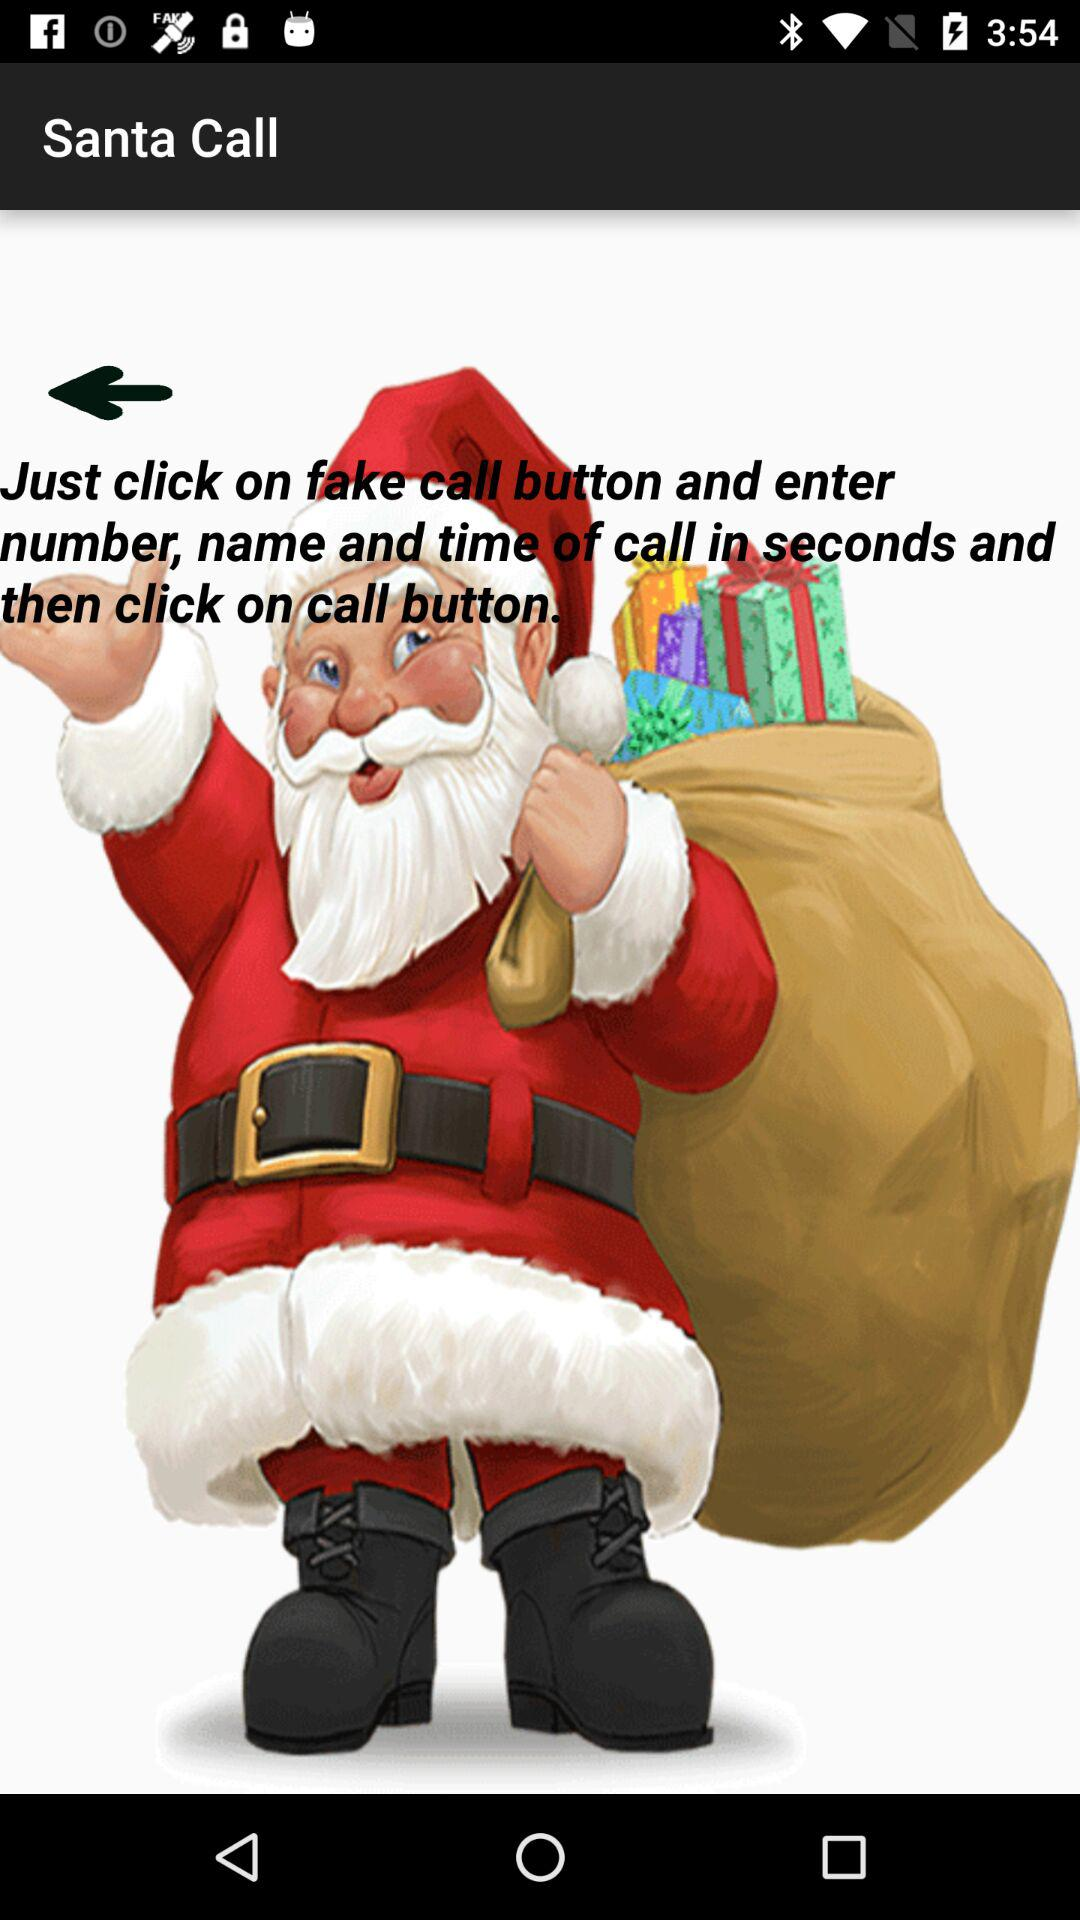What is Santa's phone number?
When the provided information is insufficient, respond with <no answer>. <no answer> 